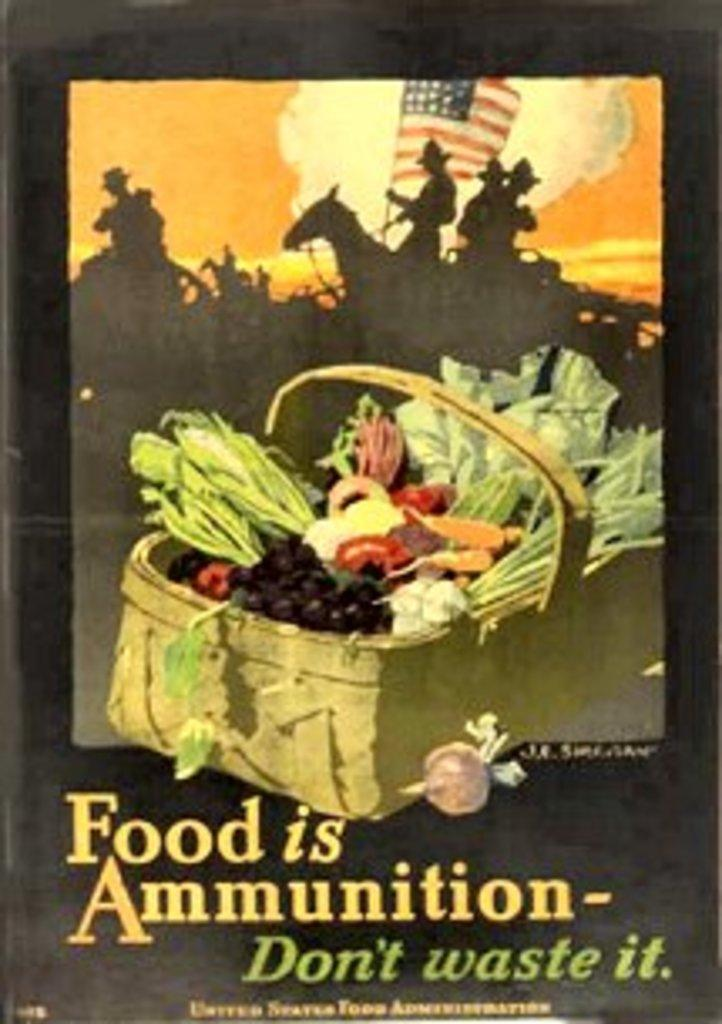Provide a one-sentence caption for the provided image. A war poster picturing a peck basket full of vegetables and declaring that food is ammunition and should not be wasted. 